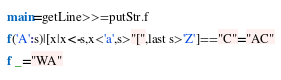<code> <loc_0><loc_0><loc_500><loc_500><_Haskell_>main=getLine>>=putStr.f
f('A':s)|[x|x<-s,x<'a',s>"[",last s>'Z']=="C"="AC"
f _="WA"</code> 